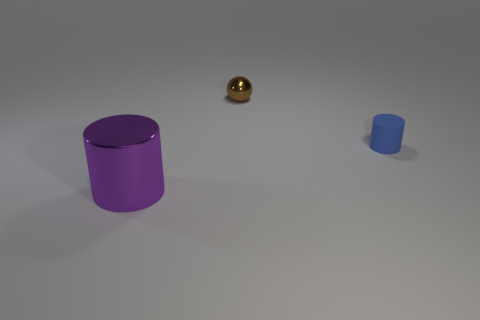What is the material of the big object in front of the blue rubber object right of the tiny thing that is on the left side of the small blue cylinder?
Provide a short and direct response. Metal. What is the small blue cylinder made of?
Keep it short and to the point. Rubber. Do the blue thing and the cylinder that is in front of the tiny blue cylinder have the same material?
Offer a terse response. No. What is the color of the small object that is right of the metallic thing behind the blue matte cylinder?
Your response must be concise. Blue. There is a object that is both behind the big shiny cylinder and on the left side of the small rubber cylinder; what is its size?
Provide a short and direct response. Small. How many other objects are there of the same shape as the tiny rubber object?
Keep it short and to the point. 1. There is a small blue matte thing; is it the same shape as the object in front of the tiny rubber object?
Make the answer very short. Yes. What number of metallic things are in front of the tiny blue thing?
Offer a very short reply. 1. Are there any other things that are the same material as the tiny blue thing?
Provide a succinct answer. No. There is a metallic object in front of the small matte cylinder; is its shape the same as the small blue rubber object?
Provide a succinct answer. Yes. 